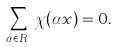<formula> <loc_0><loc_0><loc_500><loc_500>\sum _ { \alpha \in R _ { k } } \chi ( \alpha x ) = 0 .</formula> 